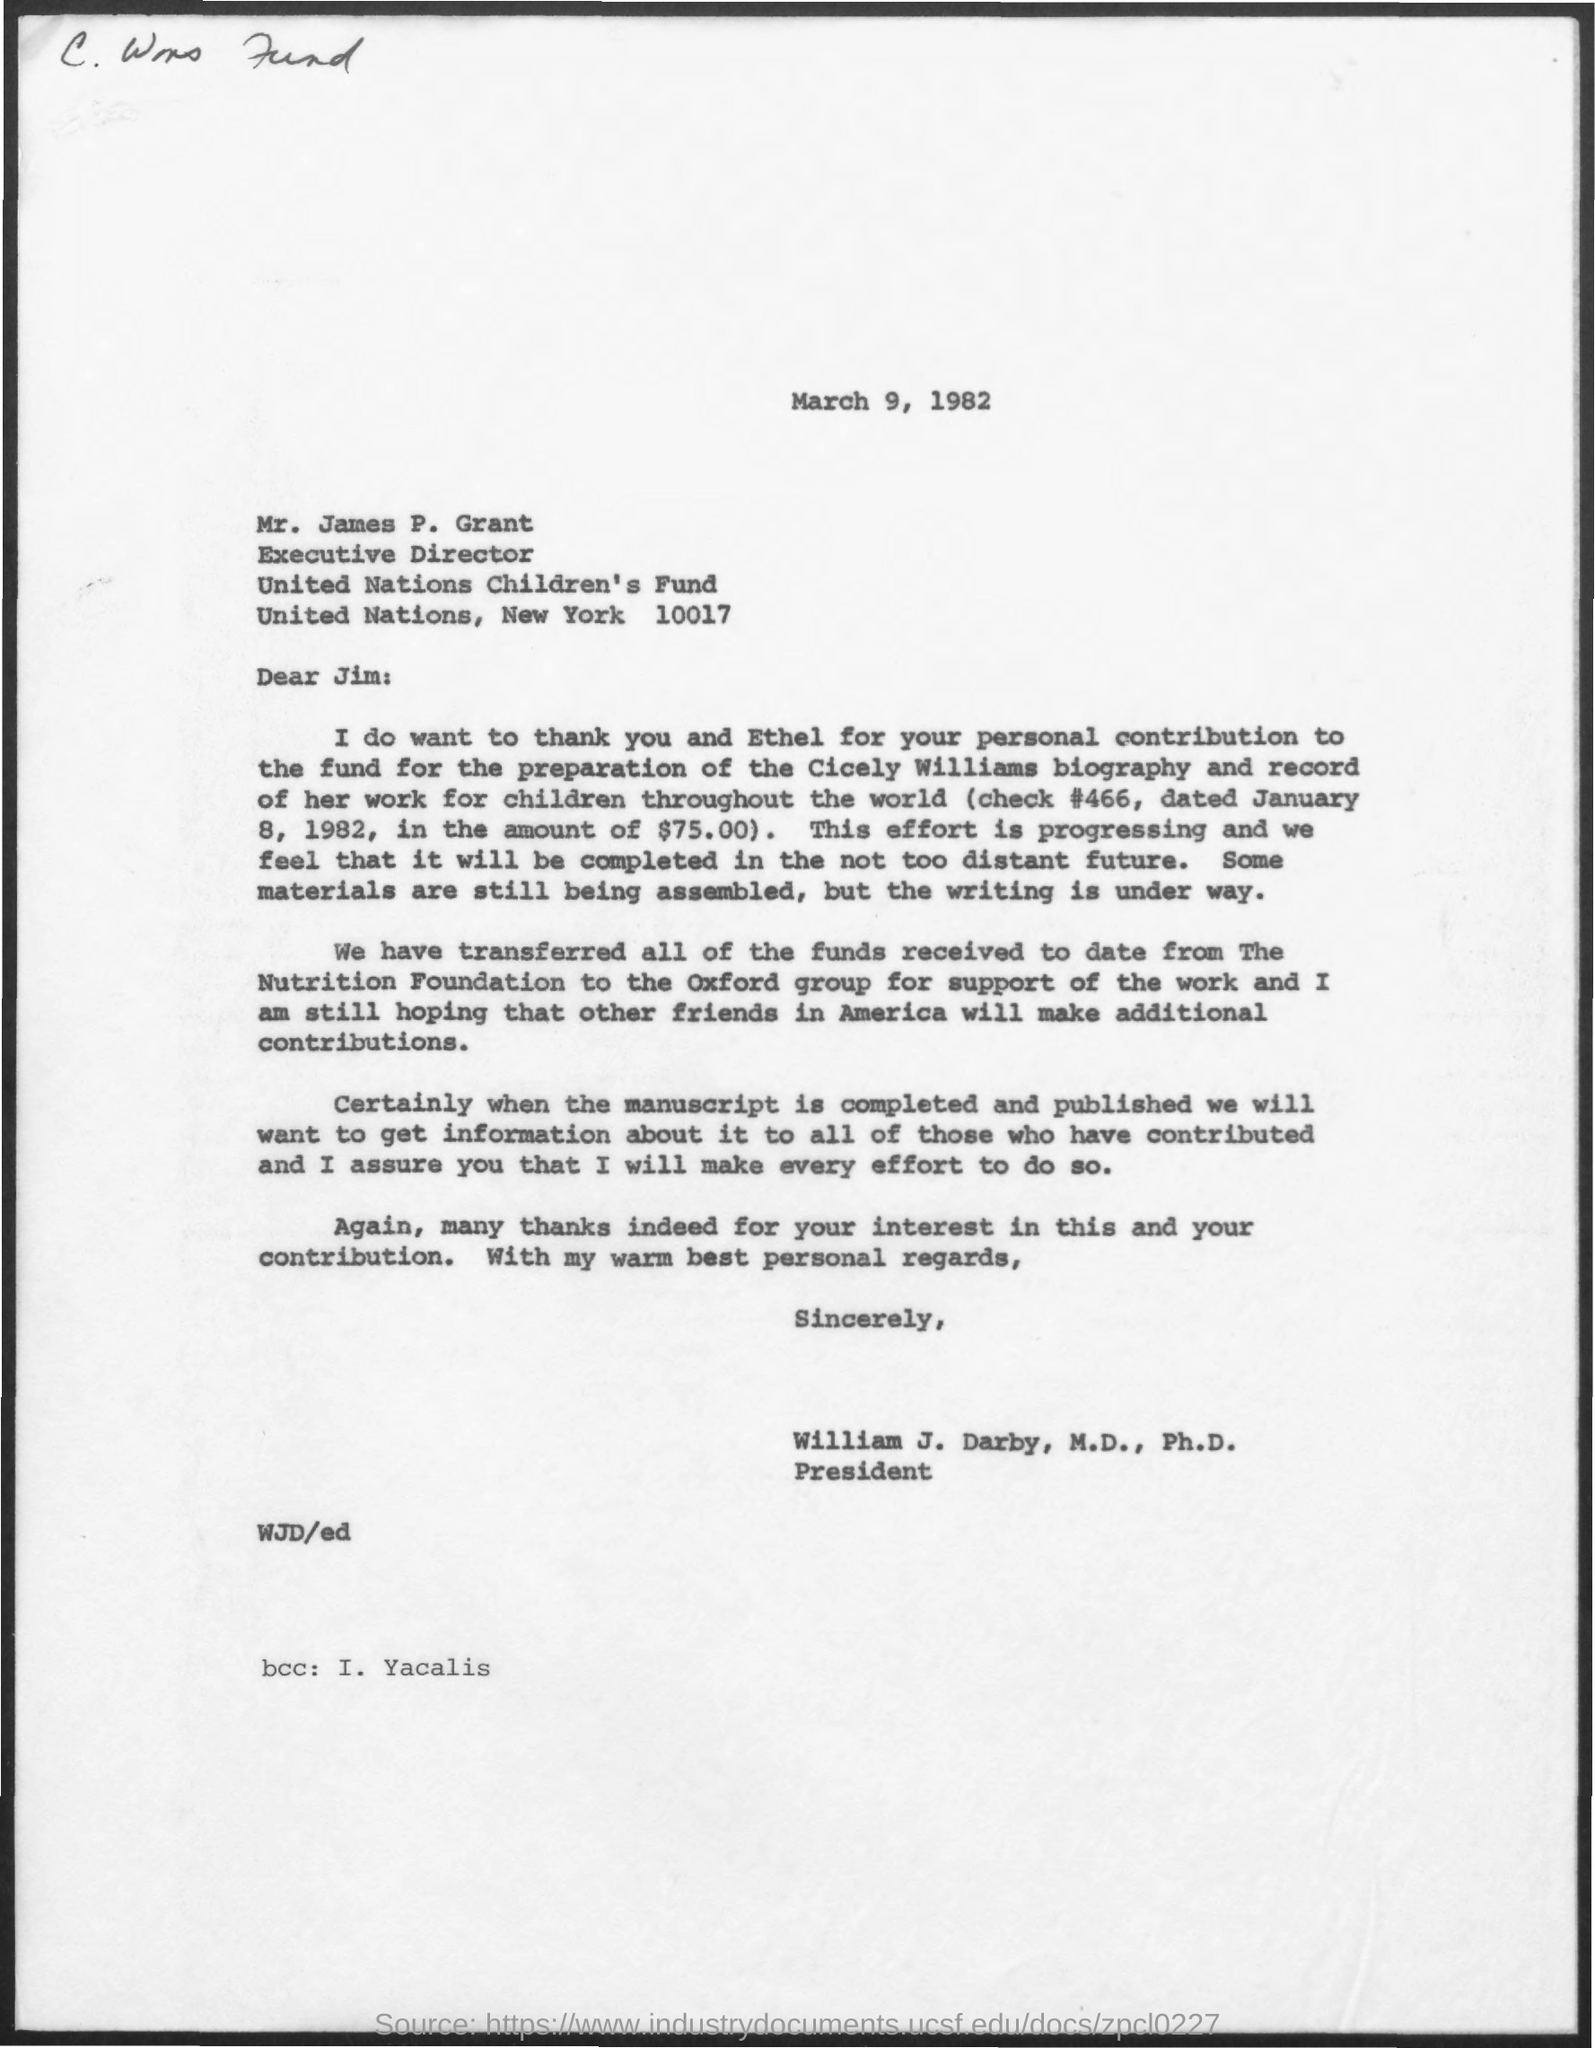Indicate a few pertinent items in this graphic. The United Nations Children's Fund (UNICEF) is located in New York. The executive director of the United Nations Children's Fund is Mr. James P. Grant. 